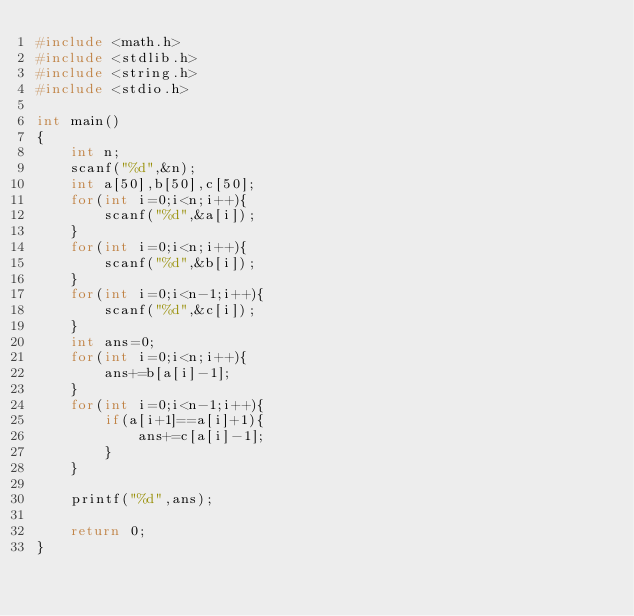<code> <loc_0><loc_0><loc_500><loc_500><_C_>#include <math.h>
#include <stdlib.h>
#include <string.h>
#include <stdio.h>

int main()
{   
    int n;
    scanf("%d",&n);
    int a[50],b[50],c[50];
    for(int i=0;i<n;i++){
        scanf("%d",&a[i]);
    }
    for(int i=0;i<n;i++){
        scanf("%d",&b[i]);
    }
    for(int i=0;i<n-1;i++){
        scanf("%d",&c[i]);
    }
    int ans=0;
    for(int i=0;i<n;i++){
        ans+=b[a[i]-1];
    }
    for(int i=0;i<n-1;i++){
        if(a[i+1]==a[i]+1){
            ans+=c[a[i]-1];
        }
    }
   
    printf("%d",ans);

    return 0;
}
</code> 